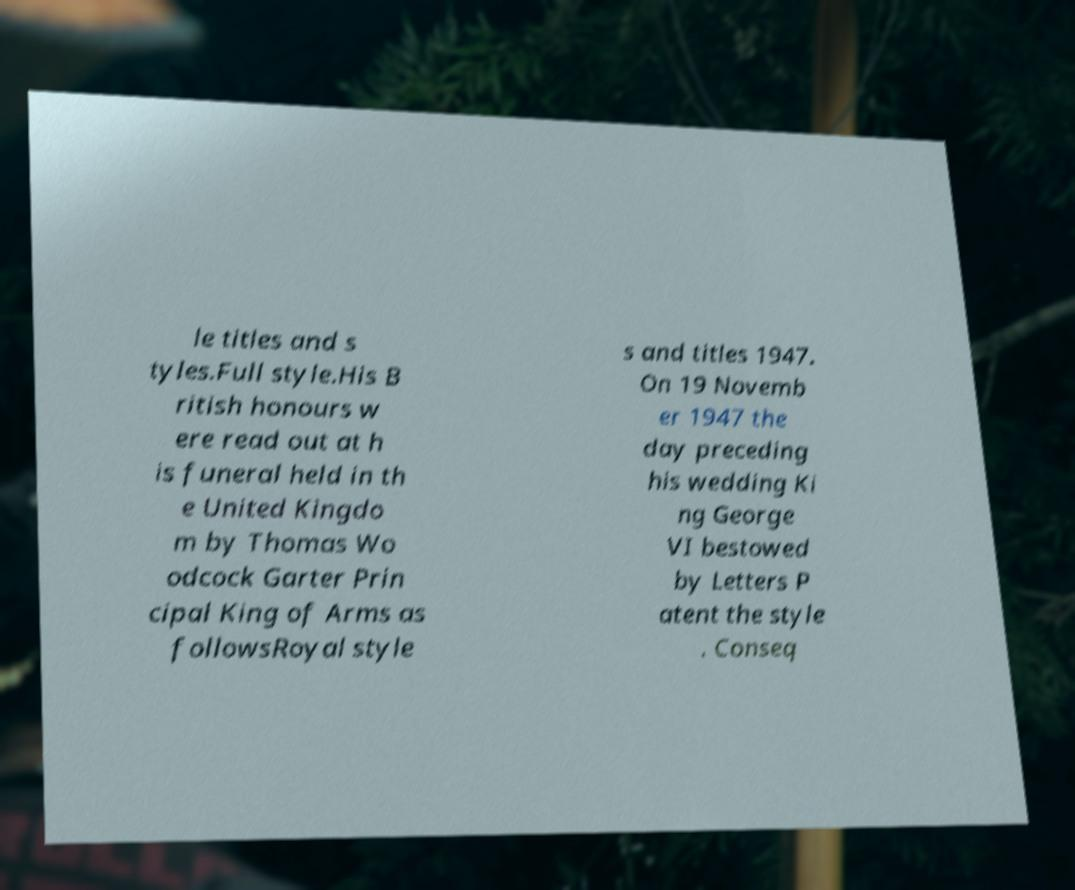I need the written content from this picture converted into text. Can you do that? le titles and s tyles.Full style.His B ritish honours w ere read out at h is funeral held in th e United Kingdo m by Thomas Wo odcock Garter Prin cipal King of Arms as followsRoyal style s and titles 1947. On 19 Novemb er 1947 the day preceding his wedding Ki ng George VI bestowed by Letters P atent the style . Conseq 